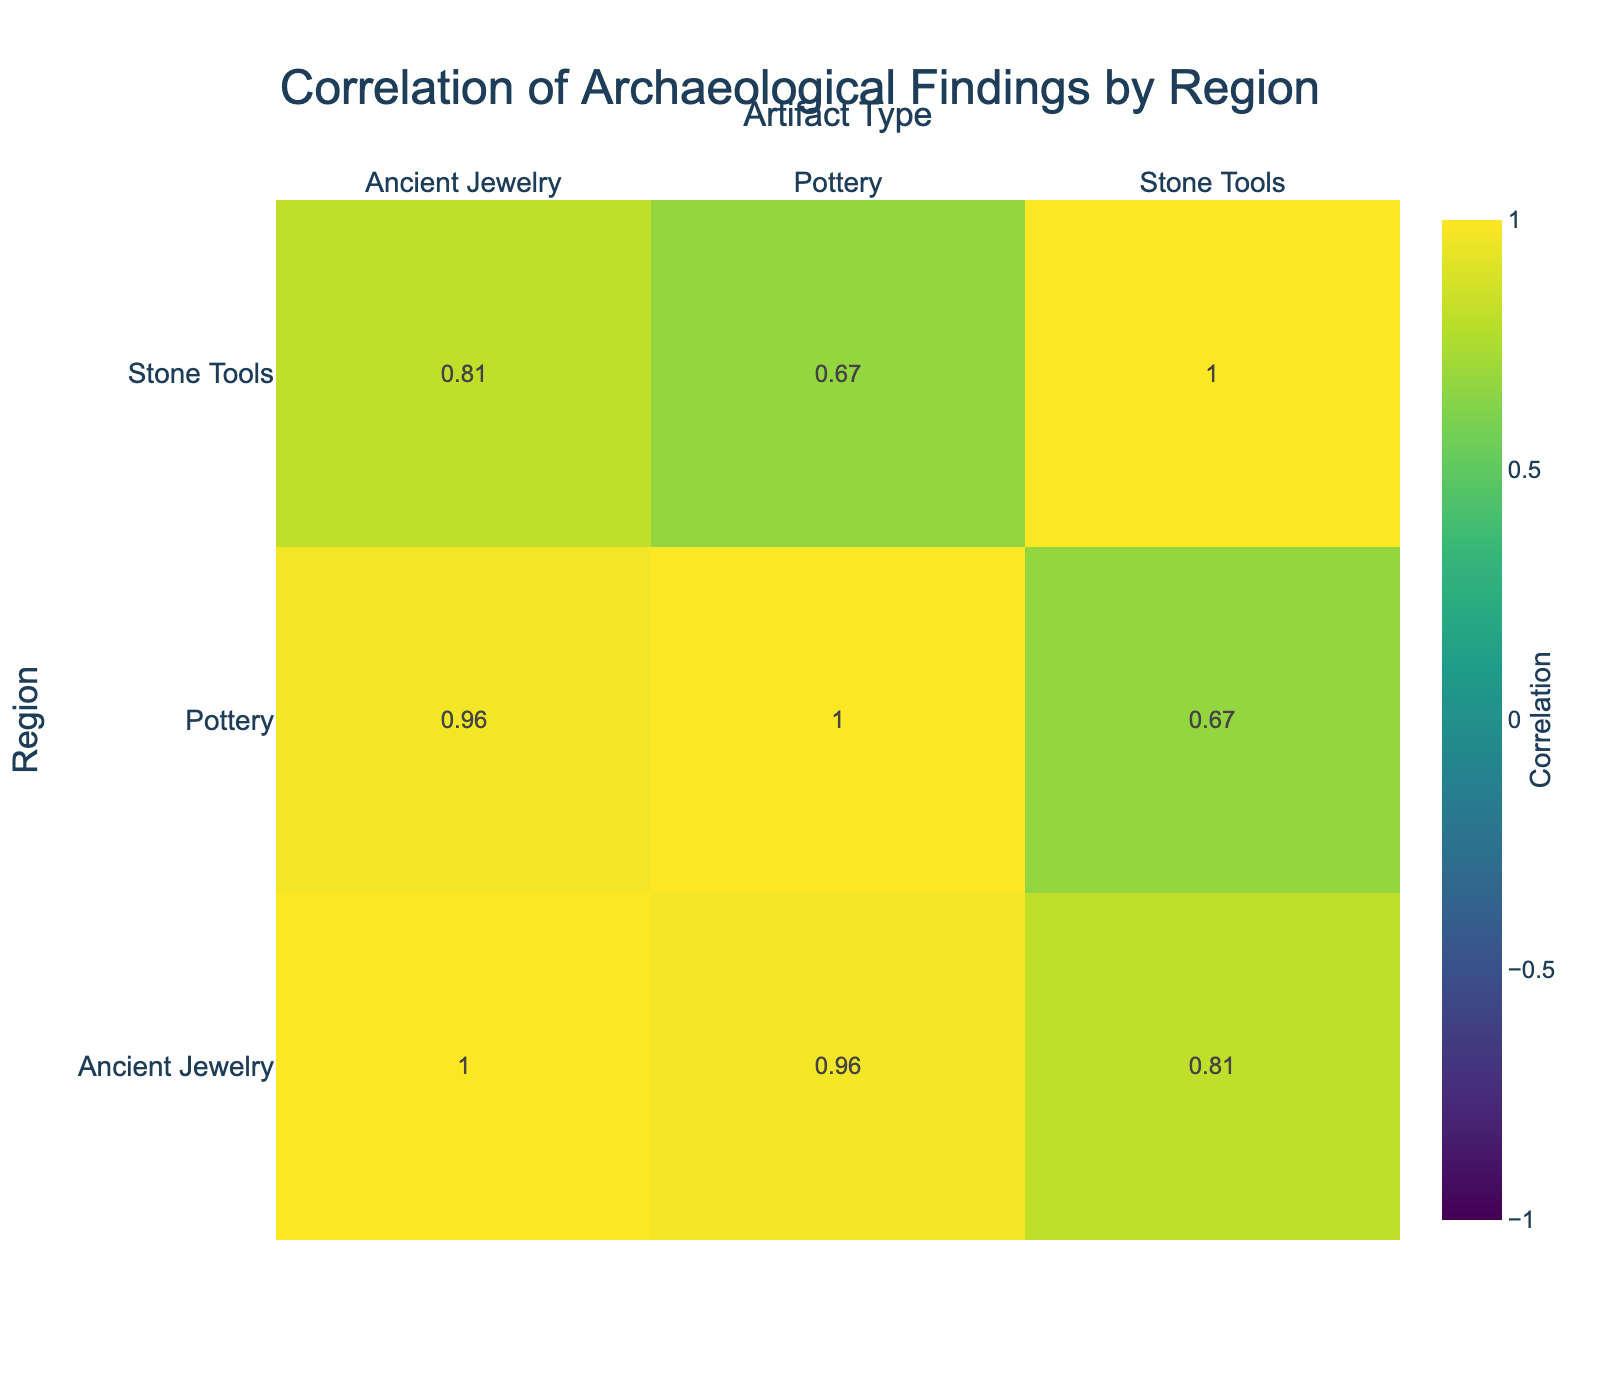What region has the highest number of pottery findings? Looking at the pottery findings for each region, Java has 200 findings, which is higher than the 180 findings in Sumatra, 150 in Bali, 90 in Kalimantan, 160 in Sulawesi, and 130 in Nusa Tenggara. Therefore, Java has the highest number of pottery findings.
Answer: Java Is the number of Stone Tool findings in Kalimantan greater than in Bali? Kalimantan has 100 findings for Stone Tools while Bali has 80. Since 100 is greater than 80, it is true that Kalimantan has more Stone Tool findings than Bali.
Answer: Yes What is the average number of Ancient Jewelry findings across all regions? Adding all Ancient Jewelry findings gives (75 + 60 + 45 + 30 + 50 + 40) = 300. There are 6 regions, so the average is 300/6 = 50.
Answer: 50 Which artifact type has the lowest total number of findings across all regions? Summing the findings for each artifact type, Stone Tools total 630, Pottery total 1110, and Ancient Jewelry total 300. Since Ancient Jewelry has the lowest total of 300, it is the artifact type with the fewest findings.
Answer: Ancient Jewelry Is there a correlation between the number of Stone Tool findings and the number of Pottery findings? Analyzing the correlation, Java (150 and 200), Sumatra (120 and 180), Bali (80 and 150), Kalimantan (100 and 90), Sulawesi (110 and 160), and Nusa Tenggara (70 and 130) shows a positive relationship. Hence, there is a correlation between the two.
Answer: Yes What is the total number of findings in Sumatra? Adding up all findings in Sumatra provides 120 (Stone Tools) + 180 (Pottery) + 60 (Ancient Jewelry) = 360. Therefore, the total number of findings in Sumatra is 360.
Answer: 360 Which region shows the highest number of Ancient Jewelry findings? Reviewing the Ancient Jewelry findings across regions, Java has 75, Sumatra has 60, Bali has 45, Kalimantan has 30, Sulawesi has 50, and Nusa Tenggara has 40. Java, with 75 findings, has the highest.
Answer: Java Which region and artifact type combination has the fewest findings? Looking for the minimum, Bali's Ancient Jewelry has the least with 45 findings, compared to others. Therefore, the fewest findings occur in Bali for Ancient Jewelry.
Answer: Bali, Ancient Jewelry What is the difference in the number of Pottery findings between Java and Nusa Tenggara? Java has 200 Pottery findings and Nusa Tenggara has 130. The difference is calculated as 200 - 130 = 70.
Answer: 70 